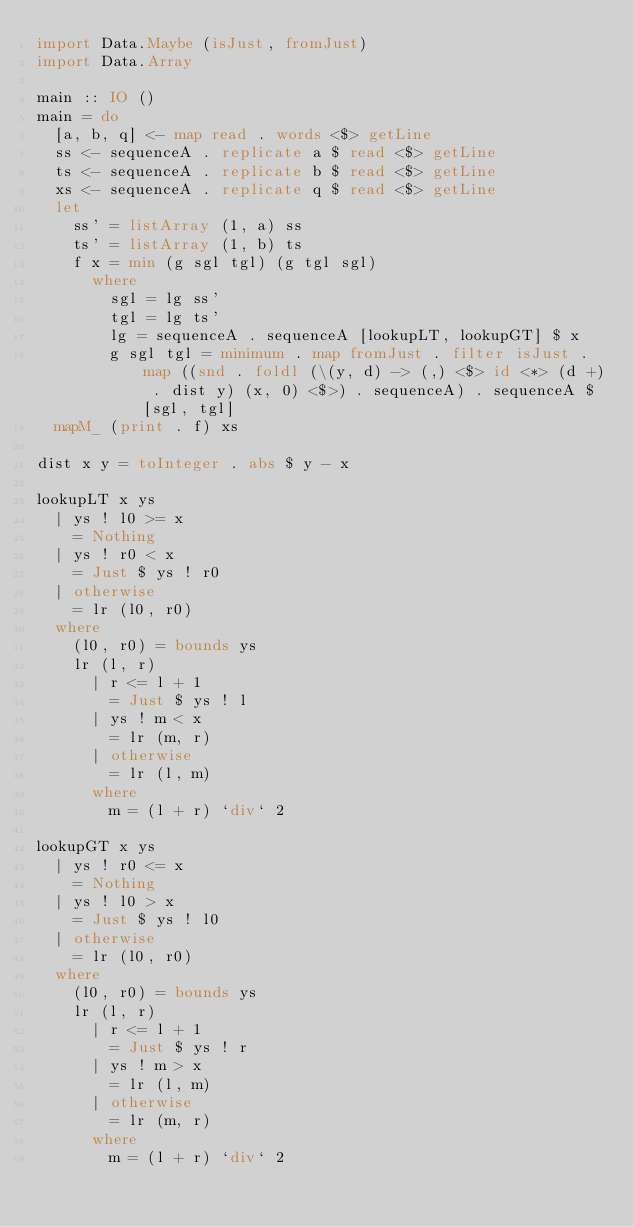<code> <loc_0><loc_0><loc_500><loc_500><_Haskell_>import Data.Maybe (isJust, fromJust)
import Data.Array

main :: IO ()
main = do
  [a, b, q] <- map read . words <$> getLine
  ss <- sequenceA . replicate a $ read <$> getLine
  ts <- sequenceA . replicate b $ read <$> getLine
  xs <- sequenceA . replicate q $ read <$> getLine
  let
    ss' = listArray (1, a) ss
    ts' = listArray (1, b) ts
    f x = min (g sgl tgl) (g tgl sgl)
      where
        sgl = lg ss'
        tgl = lg ts'
        lg = sequenceA . sequenceA [lookupLT, lookupGT] $ x
        g sgl tgl = minimum . map fromJust . filter isJust . map ((snd . foldl (\(y, d) -> (,) <$> id <*> (d +) . dist y) (x, 0) <$>) . sequenceA) . sequenceA $ [sgl, tgl]
  mapM_ (print . f) xs

dist x y = toInteger . abs $ y - x

lookupLT x ys
  | ys ! l0 >= x
    = Nothing
  | ys ! r0 < x
    = Just $ ys ! r0
  | otherwise
    = lr (l0, r0)
  where
    (l0, r0) = bounds ys
    lr (l, r)
      | r <= l + 1
        = Just $ ys ! l
      | ys ! m < x
        = lr (m, r)
      | otherwise
        = lr (l, m)
      where
        m = (l + r) `div` 2

lookupGT x ys
  | ys ! r0 <= x
    = Nothing
  | ys ! l0 > x
    = Just $ ys ! l0
  | otherwise
    = lr (l0, r0)
  where
    (l0, r0) = bounds ys
    lr (l, r)
      | r <= l + 1
        = Just $ ys ! r
      | ys ! m > x
        = lr (l, m)
      | otherwise
        = lr (m, r)
      where
        m = (l + r) `div` 2
</code> 